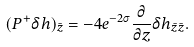<formula> <loc_0><loc_0><loc_500><loc_500>( P ^ { + } \delta h ) _ { \bar { z } } = - 4 e ^ { - 2 \sigma } \frac { \partial } { \partial z } \delta h _ { \bar { z } \bar { z } } .</formula> 